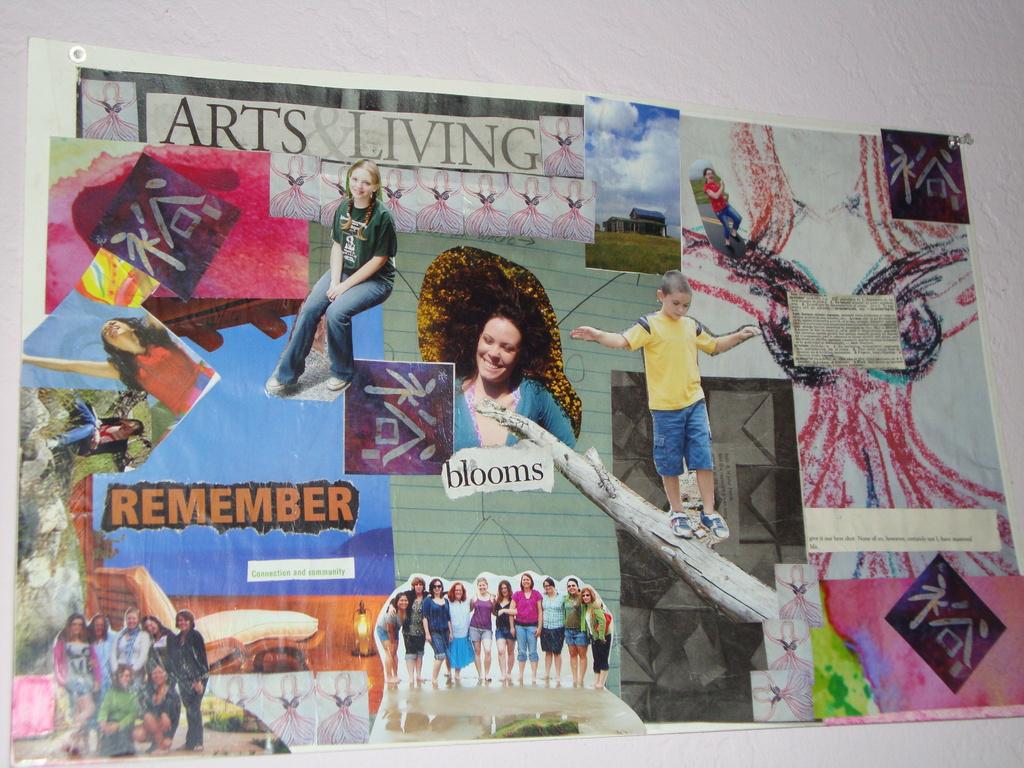What does the top of the poster say?
Provide a short and direct response. Arts living. What word is on the left in orange text?
Make the answer very short. Remember. 